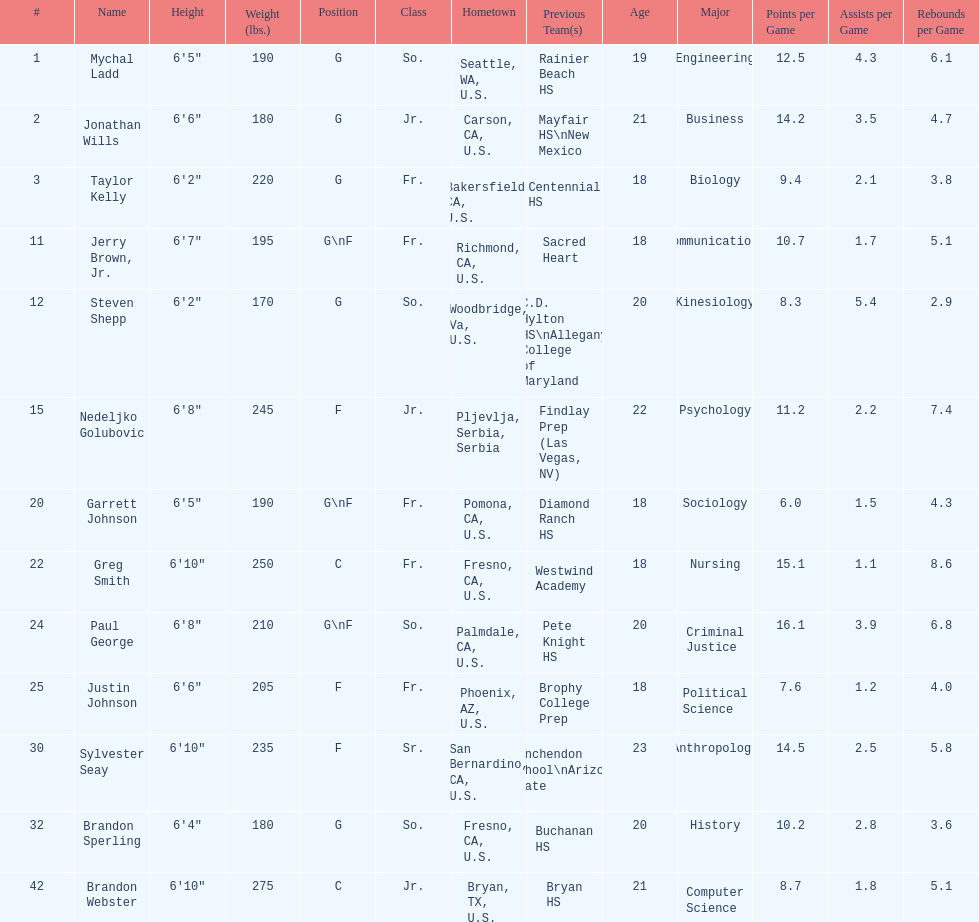Which player previously played for sacred heart? Jerry Brown, Jr. 